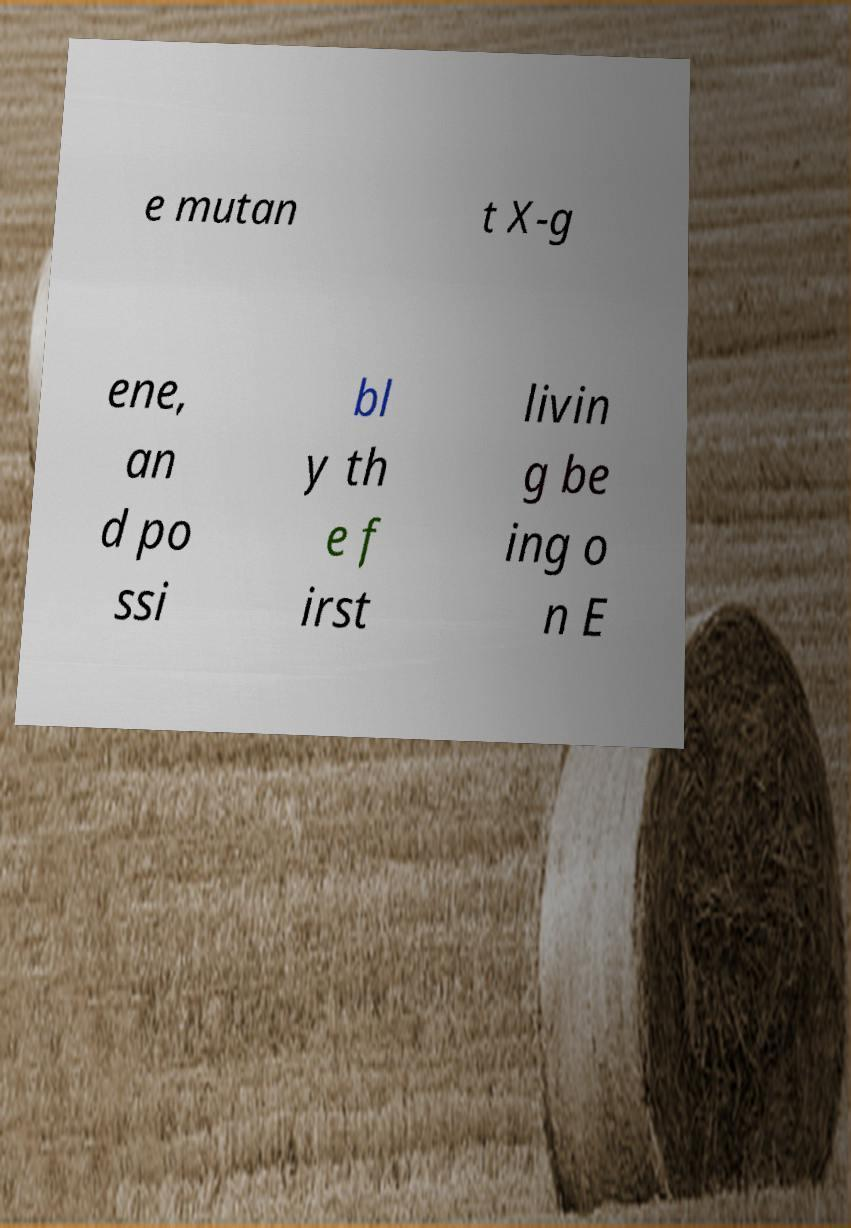Please identify and transcribe the text found in this image. e mutan t X-g ene, an d po ssi bl y th e f irst livin g be ing o n E 